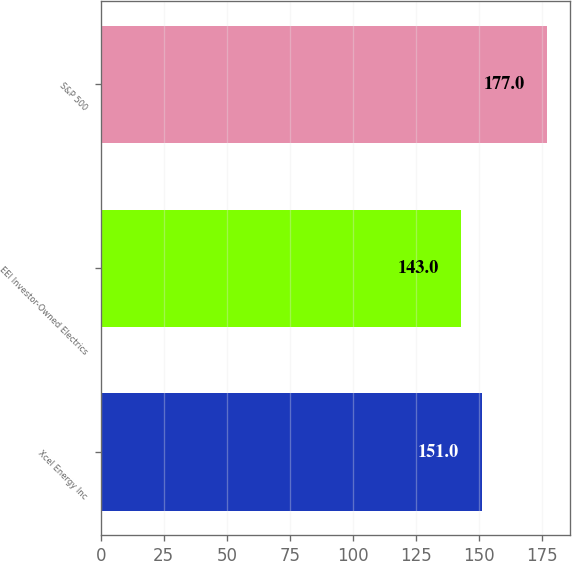<chart> <loc_0><loc_0><loc_500><loc_500><bar_chart><fcel>Xcel Energy Inc<fcel>EEI Investor-Owned Electrics<fcel>S&P 500<nl><fcel>151<fcel>143<fcel>177<nl></chart> 